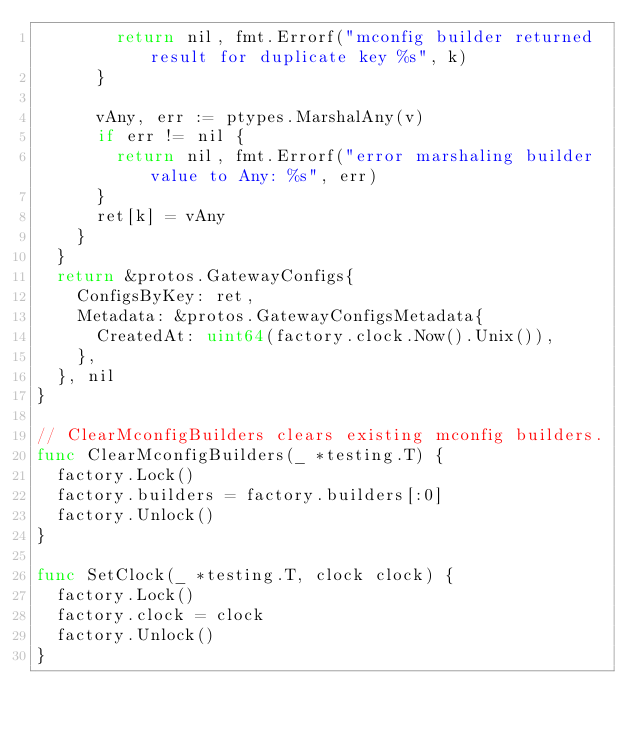Convert code to text. <code><loc_0><loc_0><loc_500><loc_500><_Go_>				return nil, fmt.Errorf("mconfig builder returned result for duplicate key %s", k)
			}

			vAny, err := ptypes.MarshalAny(v)
			if err != nil {
				return nil, fmt.Errorf("error marshaling builder value to Any: %s", err)
			}
			ret[k] = vAny
		}
	}
	return &protos.GatewayConfigs{
		ConfigsByKey: ret,
		Metadata: &protos.GatewayConfigsMetadata{
			CreatedAt: uint64(factory.clock.Now().Unix()),
		},
	}, nil
}

// ClearMconfigBuilders clears existing mconfig builders.
func ClearMconfigBuilders(_ *testing.T) {
	factory.Lock()
	factory.builders = factory.builders[:0]
	factory.Unlock()
}

func SetClock(_ *testing.T, clock clock) {
	factory.Lock()
	factory.clock = clock
	factory.Unlock()
}
</code> 